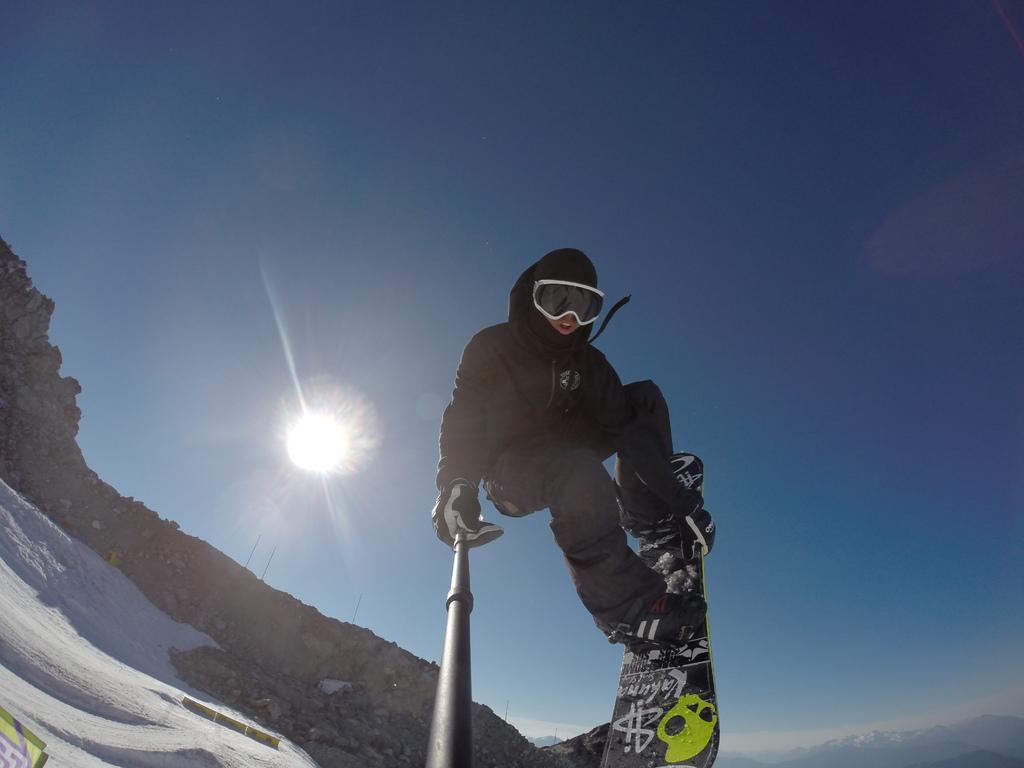How would you summarize this image in a sentence or two? In this image I can see a person on ski blade. The person is holding an object in the hand. In the background I can see the sun and the sky. 